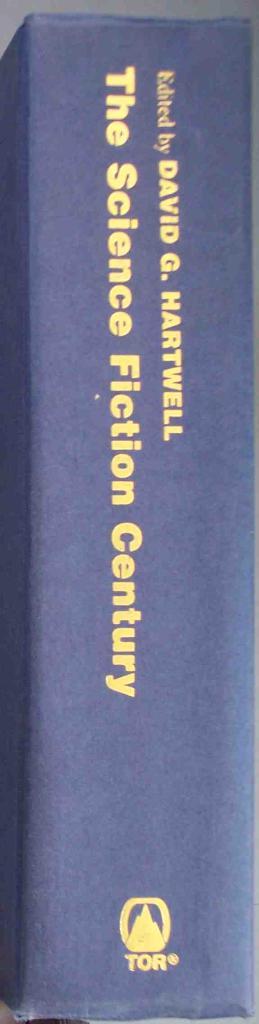What is the editor's first name?
Your answer should be compact. David. What is the title?
Keep it short and to the point. The science fiction century. 